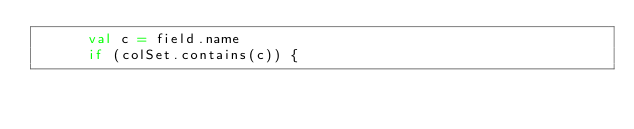<code> <loc_0><loc_0><loc_500><loc_500><_Scala_>      val c = field.name
      if (colSet.contains(c)) {</code> 